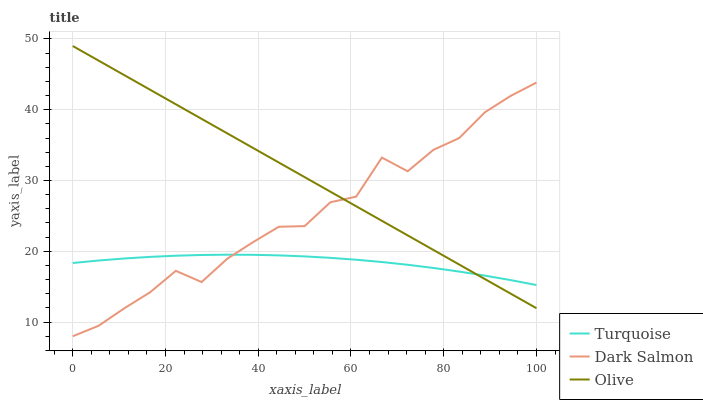Does Turquoise have the minimum area under the curve?
Answer yes or no. Yes. Does Olive have the maximum area under the curve?
Answer yes or no. Yes. Does Dark Salmon have the minimum area under the curve?
Answer yes or no. No. Does Dark Salmon have the maximum area under the curve?
Answer yes or no. No. Is Olive the smoothest?
Answer yes or no. Yes. Is Dark Salmon the roughest?
Answer yes or no. Yes. Is Turquoise the smoothest?
Answer yes or no. No. Is Turquoise the roughest?
Answer yes or no. No. Does Dark Salmon have the lowest value?
Answer yes or no. Yes. Does Turquoise have the lowest value?
Answer yes or no. No. Does Olive have the highest value?
Answer yes or no. Yes. Does Dark Salmon have the highest value?
Answer yes or no. No. Does Turquoise intersect Dark Salmon?
Answer yes or no. Yes. Is Turquoise less than Dark Salmon?
Answer yes or no. No. Is Turquoise greater than Dark Salmon?
Answer yes or no. No. 